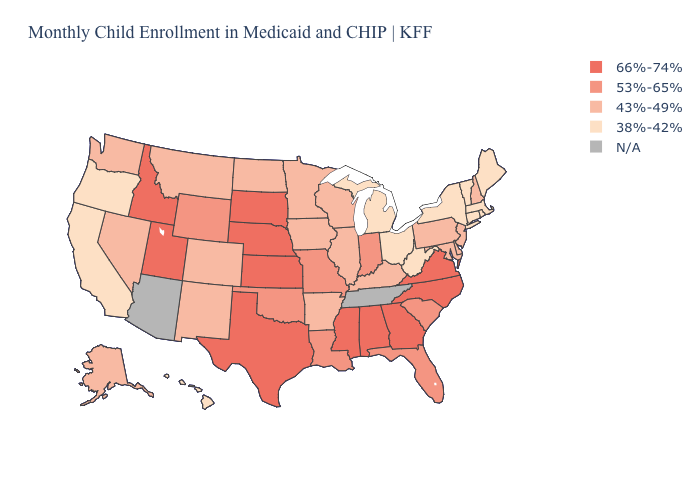Among the states that border Utah , which have the highest value?
Write a very short answer. Idaho. Among the states that border North Carolina , which have the highest value?
Concise answer only. Georgia, Virginia. What is the value of Indiana?
Quick response, please. 53%-65%. Among the states that border Texas , does Arkansas have the lowest value?
Quick response, please. Yes. Among the states that border Georgia , does Alabama have the lowest value?
Quick response, please. No. What is the lowest value in states that border Nebraska?
Keep it brief. 43%-49%. What is the highest value in the West ?
Short answer required. 66%-74%. What is the lowest value in the West?
Write a very short answer. 38%-42%. Name the states that have a value in the range 38%-42%?
Keep it brief. California, Connecticut, Hawaii, Maine, Massachusetts, Michigan, New York, Ohio, Oregon, Rhode Island, Vermont, West Virginia. What is the value of Massachusetts?
Answer briefly. 38%-42%. Name the states that have a value in the range 38%-42%?
Be succinct. California, Connecticut, Hawaii, Maine, Massachusetts, Michigan, New York, Ohio, Oregon, Rhode Island, Vermont, West Virginia. What is the value of Missouri?
Answer briefly. 53%-65%. What is the highest value in states that border New Jersey?
Write a very short answer. 43%-49%. What is the value of South Carolina?
Keep it brief. 53%-65%. 